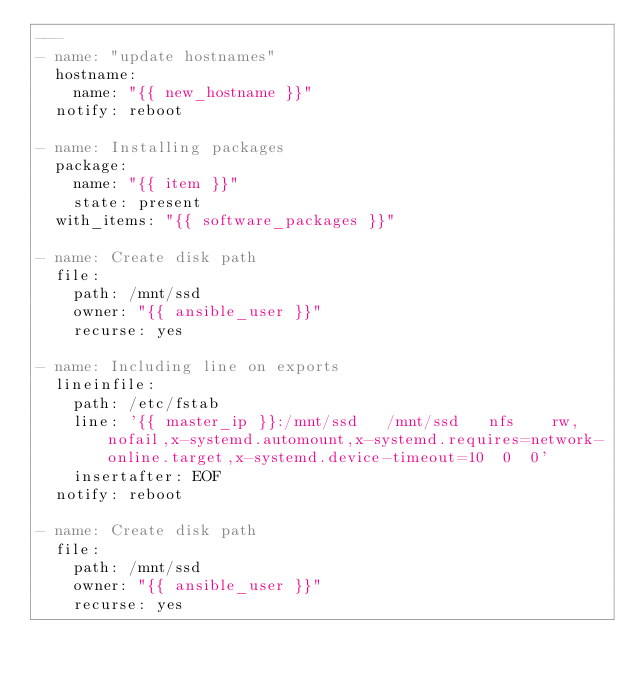<code> <loc_0><loc_0><loc_500><loc_500><_YAML_>---
- name: "update hostnames"
  hostname:
    name: "{{ new_hostname }}"
  notify: reboot

- name: Installing packages
  package:
    name: "{{ item }}"
    state: present
  with_items: "{{ software_packages }}"

- name: Create disk path
  file:
    path: /mnt/ssd
    owner: "{{ ansible_user }}"
    recurse: yes

- name: Including line on exports
  lineinfile:
    path: /etc/fstab
    line: '{{ master_ip }}:/mnt/ssd   /mnt/ssd   nfs    rw,nofail,x-systemd.automount,x-systemd.requires=network-online.target,x-systemd.device-timeout=10  0  0'
    insertafter: EOF
  notify: reboot

- name: Create disk path
  file:
    path: /mnt/ssd
    owner: "{{ ansible_user }}"
    recurse: yes
</code> 